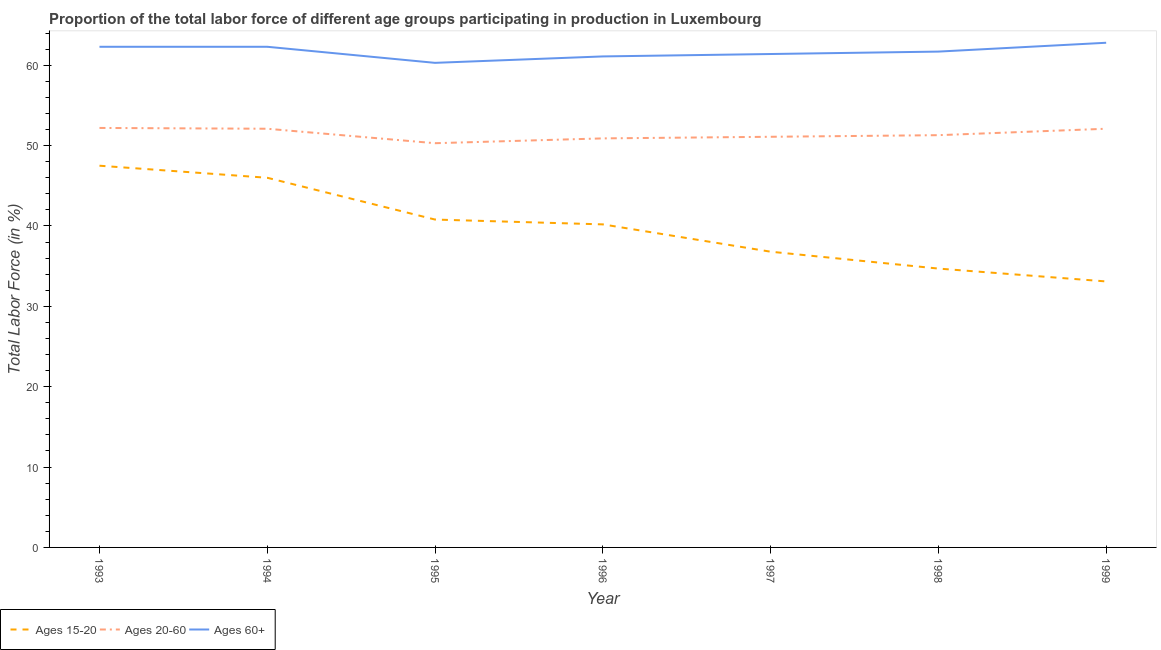How many different coloured lines are there?
Make the answer very short. 3. What is the percentage of labor force within the age group 15-20 in 1995?
Your response must be concise. 40.8. Across all years, what is the maximum percentage of labor force within the age group 15-20?
Ensure brevity in your answer.  47.5. Across all years, what is the minimum percentage of labor force above age 60?
Ensure brevity in your answer.  60.3. In which year was the percentage of labor force within the age group 15-20 maximum?
Offer a very short reply. 1993. In which year was the percentage of labor force within the age group 20-60 minimum?
Your answer should be very brief. 1995. What is the total percentage of labor force within the age group 15-20 in the graph?
Your response must be concise. 279.1. What is the difference between the percentage of labor force within the age group 20-60 in 1996 and that in 1999?
Your answer should be very brief. -1.2. What is the difference between the percentage of labor force within the age group 20-60 in 1996 and the percentage of labor force above age 60 in 1993?
Your response must be concise. -11.4. What is the average percentage of labor force above age 60 per year?
Your answer should be compact. 61.7. In the year 1993, what is the difference between the percentage of labor force within the age group 15-20 and percentage of labor force above age 60?
Give a very brief answer. -14.8. In how many years, is the percentage of labor force within the age group 20-60 greater than 12 %?
Your response must be concise. 7. What is the ratio of the percentage of labor force within the age group 15-20 in 1993 to that in 1997?
Your response must be concise. 1.29. Is the percentage of labor force within the age group 20-60 in 1994 less than that in 1997?
Keep it short and to the point. No. What is the difference between the highest and the second highest percentage of labor force within the age group 15-20?
Your answer should be very brief. 1.5. What is the difference between the highest and the lowest percentage of labor force within the age group 15-20?
Give a very brief answer. 14.4. Is the sum of the percentage of labor force within the age group 20-60 in 1993 and 1997 greater than the maximum percentage of labor force within the age group 15-20 across all years?
Offer a very short reply. Yes. Is it the case that in every year, the sum of the percentage of labor force within the age group 15-20 and percentage of labor force within the age group 20-60 is greater than the percentage of labor force above age 60?
Offer a very short reply. Yes. How many lines are there?
Offer a terse response. 3. How many years are there in the graph?
Your answer should be very brief. 7. Are the values on the major ticks of Y-axis written in scientific E-notation?
Ensure brevity in your answer.  No. Does the graph contain any zero values?
Ensure brevity in your answer.  No. Where does the legend appear in the graph?
Ensure brevity in your answer.  Bottom left. How many legend labels are there?
Your response must be concise. 3. How are the legend labels stacked?
Your answer should be very brief. Horizontal. What is the title of the graph?
Ensure brevity in your answer.  Proportion of the total labor force of different age groups participating in production in Luxembourg. What is the Total Labor Force (in %) in Ages 15-20 in 1993?
Your answer should be very brief. 47.5. What is the Total Labor Force (in %) in Ages 20-60 in 1993?
Your response must be concise. 52.2. What is the Total Labor Force (in %) of Ages 60+ in 1993?
Provide a short and direct response. 62.3. What is the Total Labor Force (in %) in Ages 15-20 in 1994?
Your response must be concise. 46. What is the Total Labor Force (in %) in Ages 20-60 in 1994?
Keep it short and to the point. 52.1. What is the Total Labor Force (in %) of Ages 60+ in 1994?
Give a very brief answer. 62.3. What is the Total Labor Force (in %) of Ages 15-20 in 1995?
Offer a very short reply. 40.8. What is the Total Labor Force (in %) in Ages 20-60 in 1995?
Offer a very short reply. 50.3. What is the Total Labor Force (in %) of Ages 60+ in 1995?
Your answer should be very brief. 60.3. What is the Total Labor Force (in %) in Ages 15-20 in 1996?
Your response must be concise. 40.2. What is the Total Labor Force (in %) in Ages 20-60 in 1996?
Your answer should be compact. 50.9. What is the Total Labor Force (in %) of Ages 60+ in 1996?
Ensure brevity in your answer.  61.1. What is the Total Labor Force (in %) of Ages 15-20 in 1997?
Provide a short and direct response. 36.8. What is the Total Labor Force (in %) in Ages 20-60 in 1997?
Offer a terse response. 51.1. What is the Total Labor Force (in %) in Ages 60+ in 1997?
Offer a terse response. 61.4. What is the Total Labor Force (in %) in Ages 15-20 in 1998?
Offer a terse response. 34.7. What is the Total Labor Force (in %) in Ages 20-60 in 1998?
Ensure brevity in your answer.  51.3. What is the Total Labor Force (in %) of Ages 60+ in 1998?
Your answer should be very brief. 61.7. What is the Total Labor Force (in %) in Ages 15-20 in 1999?
Your answer should be compact. 33.1. What is the Total Labor Force (in %) of Ages 20-60 in 1999?
Your answer should be compact. 52.1. What is the Total Labor Force (in %) in Ages 60+ in 1999?
Offer a terse response. 62.8. Across all years, what is the maximum Total Labor Force (in %) in Ages 15-20?
Offer a very short reply. 47.5. Across all years, what is the maximum Total Labor Force (in %) of Ages 20-60?
Provide a succinct answer. 52.2. Across all years, what is the maximum Total Labor Force (in %) in Ages 60+?
Keep it short and to the point. 62.8. Across all years, what is the minimum Total Labor Force (in %) in Ages 15-20?
Ensure brevity in your answer.  33.1. Across all years, what is the minimum Total Labor Force (in %) in Ages 20-60?
Offer a very short reply. 50.3. Across all years, what is the minimum Total Labor Force (in %) in Ages 60+?
Make the answer very short. 60.3. What is the total Total Labor Force (in %) in Ages 15-20 in the graph?
Your response must be concise. 279.1. What is the total Total Labor Force (in %) of Ages 20-60 in the graph?
Ensure brevity in your answer.  360. What is the total Total Labor Force (in %) of Ages 60+ in the graph?
Keep it short and to the point. 431.9. What is the difference between the Total Labor Force (in %) of Ages 60+ in 1993 and that in 1994?
Offer a very short reply. 0. What is the difference between the Total Labor Force (in %) of Ages 15-20 in 1993 and that in 1995?
Offer a very short reply. 6.7. What is the difference between the Total Labor Force (in %) of Ages 20-60 in 1993 and that in 1995?
Offer a terse response. 1.9. What is the difference between the Total Labor Force (in %) of Ages 60+ in 1993 and that in 1995?
Provide a short and direct response. 2. What is the difference between the Total Labor Force (in %) in Ages 20-60 in 1993 and that in 1996?
Provide a succinct answer. 1.3. What is the difference between the Total Labor Force (in %) in Ages 60+ in 1993 and that in 1996?
Provide a succinct answer. 1.2. What is the difference between the Total Labor Force (in %) of Ages 60+ in 1993 and that in 1997?
Offer a very short reply. 0.9. What is the difference between the Total Labor Force (in %) of Ages 15-20 in 1993 and that in 1998?
Keep it short and to the point. 12.8. What is the difference between the Total Labor Force (in %) of Ages 60+ in 1993 and that in 1998?
Offer a terse response. 0.6. What is the difference between the Total Labor Force (in %) of Ages 20-60 in 1993 and that in 1999?
Make the answer very short. 0.1. What is the difference between the Total Labor Force (in %) in Ages 20-60 in 1994 and that in 1995?
Offer a terse response. 1.8. What is the difference between the Total Labor Force (in %) of Ages 60+ in 1994 and that in 1995?
Your response must be concise. 2. What is the difference between the Total Labor Force (in %) of Ages 15-20 in 1994 and that in 1996?
Provide a succinct answer. 5.8. What is the difference between the Total Labor Force (in %) in Ages 15-20 in 1994 and that in 1998?
Provide a succinct answer. 11.3. What is the difference between the Total Labor Force (in %) of Ages 60+ in 1994 and that in 1999?
Your answer should be very brief. -0.5. What is the difference between the Total Labor Force (in %) of Ages 15-20 in 1995 and that in 1996?
Your answer should be very brief. 0.6. What is the difference between the Total Labor Force (in %) of Ages 20-60 in 1995 and that in 1996?
Provide a succinct answer. -0.6. What is the difference between the Total Labor Force (in %) of Ages 60+ in 1995 and that in 1996?
Offer a very short reply. -0.8. What is the difference between the Total Labor Force (in %) in Ages 20-60 in 1995 and that in 1997?
Your answer should be compact. -0.8. What is the difference between the Total Labor Force (in %) in Ages 60+ in 1995 and that in 1997?
Your response must be concise. -1.1. What is the difference between the Total Labor Force (in %) of Ages 20-60 in 1995 and that in 1998?
Ensure brevity in your answer.  -1. What is the difference between the Total Labor Force (in %) of Ages 60+ in 1995 and that in 1998?
Offer a terse response. -1.4. What is the difference between the Total Labor Force (in %) of Ages 15-20 in 1995 and that in 1999?
Make the answer very short. 7.7. What is the difference between the Total Labor Force (in %) in Ages 20-60 in 1996 and that in 1997?
Make the answer very short. -0.2. What is the difference between the Total Labor Force (in %) of Ages 60+ in 1996 and that in 1997?
Make the answer very short. -0.3. What is the difference between the Total Labor Force (in %) of Ages 15-20 in 1996 and that in 1998?
Give a very brief answer. 5.5. What is the difference between the Total Labor Force (in %) of Ages 15-20 in 1996 and that in 1999?
Provide a succinct answer. 7.1. What is the difference between the Total Labor Force (in %) of Ages 15-20 in 1997 and that in 1998?
Provide a succinct answer. 2.1. What is the difference between the Total Labor Force (in %) of Ages 20-60 in 1997 and that in 1998?
Provide a short and direct response. -0.2. What is the difference between the Total Labor Force (in %) of Ages 60+ in 1998 and that in 1999?
Keep it short and to the point. -1.1. What is the difference between the Total Labor Force (in %) of Ages 15-20 in 1993 and the Total Labor Force (in %) of Ages 20-60 in 1994?
Your response must be concise. -4.6. What is the difference between the Total Labor Force (in %) of Ages 15-20 in 1993 and the Total Labor Force (in %) of Ages 60+ in 1994?
Your response must be concise. -14.8. What is the difference between the Total Labor Force (in %) of Ages 15-20 in 1993 and the Total Labor Force (in %) of Ages 60+ in 1995?
Provide a succinct answer. -12.8. What is the difference between the Total Labor Force (in %) of Ages 20-60 in 1993 and the Total Labor Force (in %) of Ages 60+ in 1995?
Make the answer very short. -8.1. What is the difference between the Total Labor Force (in %) of Ages 20-60 in 1993 and the Total Labor Force (in %) of Ages 60+ in 1996?
Your response must be concise. -8.9. What is the difference between the Total Labor Force (in %) in Ages 15-20 in 1993 and the Total Labor Force (in %) in Ages 20-60 in 1997?
Provide a succinct answer. -3.6. What is the difference between the Total Labor Force (in %) of Ages 15-20 in 1993 and the Total Labor Force (in %) of Ages 60+ in 1998?
Your response must be concise. -14.2. What is the difference between the Total Labor Force (in %) of Ages 15-20 in 1993 and the Total Labor Force (in %) of Ages 20-60 in 1999?
Your answer should be very brief. -4.6. What is the difference between the Total Labor Force (in %) of Ages 15-20 in 1993 and the Total Labor Force (in %) of Ages 60+ in 1999?
Offer a very short reply. -15.3. What is the difference between the Total Labor Force (in %) of Ages 15-20 in 1994 and the Total Labor Force (in %) of Ages 60+ in 1995?
Your answer should be compact. -14.3. What is the difference between the Total Labor Force (in %) in Ages 20-60 in 1994 and the Total Labor Force (in %) in Ages 60+ in 1995?
Your answer should be compact. -8.2. What is the difference between the Total Labor Force (in %) of Ages 15-20 in 1994 and the Total Labor Force (in %) of Ages 60+ in 1996?
Your answer should be compact. -15.1. What is the difference between the Total Labor Force (in %) of Ages 15-20 in 1994 and the Total Labor Force (in %) of Ages 20-60 in 1997?
Give a very brief answer. -5.1. What is the difference between the Total Labor Force (in %) of Ages 15-20 in 1994 and the Total Labor Force (in %) of Ages 60+ in 1997?
Offer a terse response. -15.4. What is the difference between the Total Labor Force (in %) of Ages 20-60 in 1994 and the Total Labor Force (in %) of Ages 60+ in 1997?
Your answer should be very brief. -9.3. What is the difference between the Total Labor Force (in %) of Ages 15-20 in 1994 and the Total Labor Force (in %) of Ages 60+ in 1998?
Keep it short and to the point. -15.7. What is the difference between the Total Labor Force (in %) of Ages 20-60 in 1994 and the Total Labor Force (in %) of Ages 60+ in 1998?
Give a very brief answer. -9.6. What is the difference between the Total Labor Force (in %) in Ages 15-20 in 1994 and the Total Labor Force (in %) in Ages 20-60 in 1999?
Keep it short and to the point. -6.1. What is the difference between the Total Labor Force (in %) in Ages 15-20 in 1994 and the Total Labor Force (in %) in Ages 60+ in 1999?
Give a very brief answer. -16.8. What is the difference between the Total Labor Force (in %) in Ages 20-60 in 1994 and the Total Labor Force (in %) in Ages 60+ in 1999?
Make the answer very short. -10.7. What is the difference between the Total Labor Force (in %) in Ages 15-20 in 1995 and the Total Labor Force (in %) in Ages 20-60 in 1996?
Your response must be concise. -10.1. What is the difference between the Total Labor Force (in %) of Ages 15-20 in 1995 and the Total Labor Force (in %) of Ages 60+ in 1996?
Keep it short and to the point. -20.3. What is the difference between the Total Labor Force (in %) of Ages 15-20 in 1995 and the Total Labor Force (in %) of Ages 20-60 in 1997?
Offer a terse response. -10.3. What is the difference between the Total Labor Force (in %) in Ages 15-20 in 1995 and the Total Labor Force (in %) in Ages 60+ in 1997?
Give a very brief answer. -20.6. What is the difference between the Total Labor Force (in %) of Ages 15-20 in 1995 and the Total Labor Force (in %) of Ages 20-60 in 1998?
Offer a terse response. -10.5. What is the difference between the Total Labor Force (in %) of Ages 15-20 in 1995 and the Total Labor Force (in %) of Ages 60+ in 1998?
Offer a very short reply. -20.9. What is the difference between the Total Labor Force (in %) in Ages 20-60 in 1995 and the Total Labor Force (in %) in Ages 60+ in 1999?
Ensure brevity in your answer.  -12.5. What is the difference between the Total Labor Force (in %) in Ages 15-20 in 1996 and the Total Labor Force (in %) in Ages 60+ in 1997?
Provide a succinct answer. -21.2. What is the difference between the Total Labor Force (in %) in Ages 15-20 in 1996 and the Total Labor Force (in %) in Ages 20-60 in 1998?
Keep it short and to the point. -11.1. What is the difference between the Total Labor Force (in %) of Ages 15-20 in 1996 and the Total Labor Force (in %) of Ages 60+ in 1998?
Your answer should be compact. -21.5. What is the difference between the Total Labor Force (in %) in Ages 15-20 in 1996 and the Total Labor Force (in %) in Ages 20-60 in 1999?
Offer a very short reply. -11.9. What is the difference between the Total Labor Force (in %) in Ages 15-20 in 1996 and the Total Labor Force (in %) in Ages 60+ in 1999?
Provide a short and direct response. -22.6. What is the difference between the Total Labor Force (in %) in Ages 15-20 in 1997 and the Total Labor Force (in %) in Ages 60+ in 1998?
Keep it short and to the point. -24.9. What is the difference between the Total Labor Force (in %) in Ages 15-20 in 1997 and the Total Labor Force (in %) in Ages 20-60 in 1999?
Provide a short and direct response. -15.3. What is the difference between the Total Labor Force (in %) of Ages 15-20 in 1997 and the Total Labor Force (in %) of Ages 60+ in 1999?
Keep it short and to the point. -26. What is the difference between the Total Labor Force (in %) of Ages 20-60 in 1997 and the Total Labor Force (in %) of Ages 60+ in 1999?
Offer a very short reply. -11.7. What is the difference between the Total Labor Force (in %) in Ages 15-20 in 1998 and the Total Labor Force (in %) in Ages 20-60 in 1999?
Ensure brevity in your answer.  -17.4. What is the difference between the Total Labor Force (in %) in Ages 15-20 in 1998 and the Total Labor Force (in %) in Ages 60+ in 1999?
Ensure brevity in your answer.  -28.1. What is the difference between the Total Labor Force (in %) in Ages 20-60 in 1998 and the Total Labor Force (in %) in Ages 60+ in 1999?
Provide a short and direct response. -11.5. What is the average Total Labor Force (in %) in Ages 15-20 per year?
Your answer should be compact. 39.87. What is the average Total Labor Force (in %) in Ages 20-60 per year?
Ensure brevity in your answer.  51.43. What is the average Total Labor Force (in %) of Ages 60+ per year?
Your answer should be very brief. 61.7. In the year 1993, what is the difference between the Total Labor Force (in %) of Ages 15-20 and Total Labor Force (in %) of Ages 20-60?
Your answer should be compact. -4.7. In the year 1993, what is the difference between the Total Labor Force (in %) of Ages 15-20 and Total Labor Force (in %) of Ages 60+?
Make the answer very short. -14.8. In the year 1994, what is the difference between the Total Labor Force (in %) of Ages 15-20 and Total Labor Force (in %) of Ages 20-60?
Your answer should be compact. -6.1. In the year 1994, what is the difference between the Total Labor Force (in %) in Ages 15-20 and Total Labor Force (in %) in Ages 60+?
Offer a very short reply. -16.3. In the year 1994, what is the difference between the Total Labor Force (in %) in Ages 20-60 and Total Labor Force (in %) in Ages 60+?
Your response must be concise. -10.2. In the year 1995, what is the difference between the Total Labor Force (in %) of Ages 15-20 and Total Labor Force (in %) of Ages 20-60?
Your answer should be compact. -9.5. In the year 1995, what is the difference between the Total Labor Force (in %) in Ages 15-20 and Total Labor Force (in %) in Ages 60+?
Keep it short and to the point. -19.5. In the year 1996, what is the difference between the Total Labor Force (in %) of Ages 15-20 and Total Labor Force (in %) of Ages 60+?
Your answer should be very brief. -20.9. In the year 1996, what is the difference between the Total Labor Force (in %) in Ages 20-60 and Total Labor Force (in %) in Ages 60+?
Your answer should be very brief. -10.2. In the year 1997, what is the difference between the Total Labor Force (in %) in Ages 15-20 and Total Labor Force (in %) in Ages 20-60?
Provide a succinct answer. -14.3. In the year 1997, what is the difference between the Total Labor Force (in %) in Ages 15-20 and Total Labor Force (in %) in Ages 60+?
Your response must be concise. -24.6. In the year 1998, what is the difference between the Total Labor Force (in %) in Ages 15-20 and Total Labor Force (in %) in Ages 20-60?
Offer a very short reply. -16.6. In the year 1998, what is the difference between the Total Labor Force (in %) in Ages 15-20 and Total Labor Force (in %) in Ages 60+?
Your response must be concise. -27. In the year 1999, what is the difference between the Total Labor Force (in %) of Ages 15-20 and Total Labor Force (in %) of Ages 60+?
Provide a short and direct response. -29.7. What is the ratio of the Total Labor Force (in %) in Ages 15-20 in 1993 to that in 1994?
Your response must be concise. 1.03. What is the ratio of the Total Labor Force (in %) in Ages 20-60 in 1993 to that in 1994?
Offer a very short reply. 1. What is the ratio of the Total Labor Force (in %) of Ages 60+ in 1993 to that in 1994?
Offer a very short reply. 1. What is the ratio of the Total Labor Force (in %) in Ages 15-20 in 1993 to that in 1995?
Provide a succinct answer. 1.16. What is the ratio of the Total Labor Force (in %) in Ages 20-60 in 1993 to that in 1995?
Offer a very short reply. 1.04. What is the ratio of the Total Labor Force (in %) in Ages 60+ in 1993 to that in 1995?
Keep it short and to the point. 1.03. What is the ratio of the Total Labor Force (in %) of Ages 15-20 in 1993 to that in 1996?
Your answer should be compact. 1.18. What is the ratio of the Total Labor Force (in %) of Ages 20-60 in 1993 to that in 1996?
Give a very brief answer. 1.03. What is the ratio of the Total Labor Force (in %) of Ages 60+ in 1993 to that in 1996?
Keep it short and to the point. 1.02. What is the ratio of the Total Labor Force (in %) in Ages 15-20 in 1993 to that in 1997?
Provide a succinct answer. 1.29. What is the ratio of the Total Labor Force (in %) of Ages 20-60 in 1993 to that in 1997?
Provide a short and direct response. 1.02. What is the ratio of the Total Labor Force (in %) of Ages 60+ in 1993 to that in 1997?
Your answer should be compact. 1.01. What is the ratio of the Total Labor Force (in %) of Ages 15-20 in 1993 to that in 1998?
Offer a terse response. 1.37. What is the ratio of the Total Labor Force (in %) of Ages 20-60 in 1993 to that in 1998?
Provide a succinct answer. 1.02. What is the ratio of the Total Labor Force (in %) of Ages 60+ in 1993 to that in 1998?
Provide a short and direct response. 1.01. What is the ratio of the Total Labor Force (in %) in Ages 15-20 in 1993 to that in 1999?
Provide a short and direct response. 1.44. What is the ratio of the Total Labor Force (in %) of Ages 20-60 in 1993 to that in 1999?
Your response must be concise. 1. What is the ratio of the Total Labor Force (in %) in Ages 15-20 in 1994 to that in 1995?
Provide a short and direct response. 1.13. What is the ratio of the Total Labor Force (in %) in Ages 20-60 in 1994 to that in 1995?
Your answer should be very brief. 1.04. What is the ratio of the Total Labor Force (in %) in Ages 60+ in 1994 to that in 1995?
Ensure brevity in your answer.  1.03. What is the ratio of the Total Labor Force (in %) of Ages 15-20 in 1994 to that in 1996?
Make the answer very short. 1.14. What is the ratio of the Total Labor Force (in %) of Ages 20-60 in 1994 to that in 1996?
Ensure brevity in your answer.  1.02. What is the ratio of the Total Labor Force (in %) in Ages 60+ in 1994 to that in 1996?
Make the answer very short. 1.02. What is the ratio of the Total Labor Force (in %) of Ages 15-20 in 1994 to that in 1997?
Give a very brief answer. 1.25. What is the ratio of the Total Labor Force (in %) of Ages 20-60 in 1994 to that in 1997?
Make the answer very short. 1.02. What is the ratio of the Total Labor Force (in %) in Ages 60+ in 1994 to that in 1997?
Offer a very short reply. 1.01. What is the ratio of the Total Labor Force (in %) in Ages 15-20 in 1994 to that in 1998?
Your answer should be very brief. 1.33. What is the ratio of the Total Labor Force (in %) in Ages 20-60 in 1994 to that in 1998?
Offer a terse response. 1.02. What is the ratio of the Total Labor Force (in %) in Ages 60+ in 1994 to that in 1998?
Offer a terse response. 1.01. What is the ratio of the Total Labor Force (in %) in Ages 15-20 in 1994 to that in 1999?
Your response must be concise. 1.39. What is the ratio of the Total Labor Force (in %) of Ages 15-20 in 1995 to that in 1996?
Keep it short and to the point. 1.01. What is the ratio of the Total Labor Force (in %) in Ages 60+ in 1995 to that in 1996?
Give a very brief answer. 0.99. What is the ratio of the Total Labor Force (in %) of Ages 15-20 in 1995 to that in 1997?
Your answer should be very brief. 1.11. What is the ratio of the Total Labor Force (in %) of Ages 20-60 in 1995 to that in 1997?
Your answer should be very brief. 0.98. What is the ratio of the Total Labor Force (in %) of Ages 60+ in 1995 to that in 1997?
Ensure brevity in your answer.  0.98. What is the ratio of the Total Labor Force (in %) in Ages 15-20 in 1995 to that in 1998?
Give a very brief answer. 1.18. What is the ratio of the Total Labor Force (in %) of Ages 20-60 in 1995 to that in 1998?
Your response must be concise. 0.98. What is the ratio of the Total Labor Force (in %) of Ages 60+ in 1995 to that in 1998?
Your answer should be compact. 0.98. What is the ratio of the Total Labor Force (in %) in Ages 15-20 in 1995 to that in 1999?
Keep it short and to the point. 1.23. What is the ratio of the Total Labor Force (in %) in Ages 20-60 in 1995 to that in 1999?
Keep it short and to the point. 0.97. What is the ratio of the Total Labor Force (in %) of Ages 60+ in 1995 to that in 1999?
Your answer should be very brief. 0.96. What is the ratio of the Total Labor Force (in %) in Ages 15-20 in 1996 to that in 1997?
Your answer should be compact. 1.09. What is the ratio of the Total Labor Force (in %) of Ages 20-60 in 1996 to that in 1997?
Your response must be concise. 1. What is the ratio of the Total Labor Force (in %) of Ages 60+ in 1996 to that in 1997?
Ensure brevity in your answer.  1. What is the ratio of the Total Labor Force (in %) of Ages 15-20 in 1996 to that in 1998?
Provide a succinct answer. 1.16. What is the ratio of the Total Labor Force (in %) in Ages 60+ in 1996 to that in 1998?
Give a very brief answer. 0.99. What is the ratio of the Total Labor Force (in %) of Ages 15-20 in 1996 to that in 1999?
Give a very brief answer. 1.21. What is the ratio of the Total Labor Force (in %) of Ages 60+ in 1996 to that in 1999?
Provide a short and direct response. 0.97. What is the ratio of the Total Labor Force (in %) in Ages 15-20 in 1997 to that in 1998?
Ensure brevity in your answer.  1.06. What is the ratio of the Total Labor Force (in %) in Ages 20-60 in 1997 to that in 1998?
Keep it short and to the point. 1. What is the ratio of the Total Labor Force (in %) in Ages 15-20 in 1997 to that in 1999?
Keep it short and to the point. 1.11. What is the ratio of the Total Labor Force (in %) of Ages 20-60 in 1997 to that in 1999?
Make the answer very short. 0.98. What is the ratio of the Total Labor Force (in %) in Ages 60+ in 1997 to that in 1999?
Your answer should be compact. 0.98. What is the ratio of the Total Labor Force (in %) in Ages 15-20 in 1998 to that in 1999?
Your response must be concise. 1.05. What is the ratio of the Total Labor Force (in %) in Ages 20-60 in 1998 to that in 1999?
Ensure brevity in your answer.  0.98. What is the ratio of the Total Labor Force (in %) of Ages 60+ in 1998 to that in 1999?
Your response must be concise. 0.98. What is the difference between the highest and the lowest Total Labor Force (in %) in Ages 15-20?
Give a very brief answer. 14.4. What is the difference between the highest and the lowest Total Labor Force (in %) in Ages 60+?
Your answer should be compact. 2.5. 